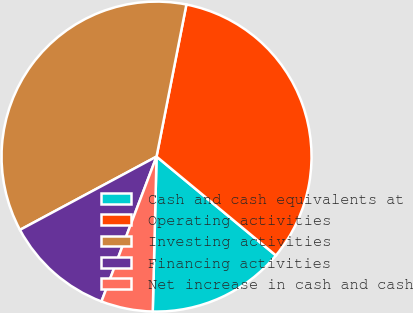<chart> <loc_0><loc_0><loc_500><loc_500><pie_chart><fcel>Cash and cash equivalents at<fcel>Operating activities<fcel>Investing activities<fcel>Financing activities<fcel>Net increase in cash and cash<nl><fcel>14.38%<fcel>32.92%<fcel>35.92%<fcel>11.38%<fcel>5.39%<nl></chart> 